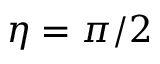<formula> <loc_0><loc_0><loc_500><loc_500>\eta = \pi / 2</formula> 